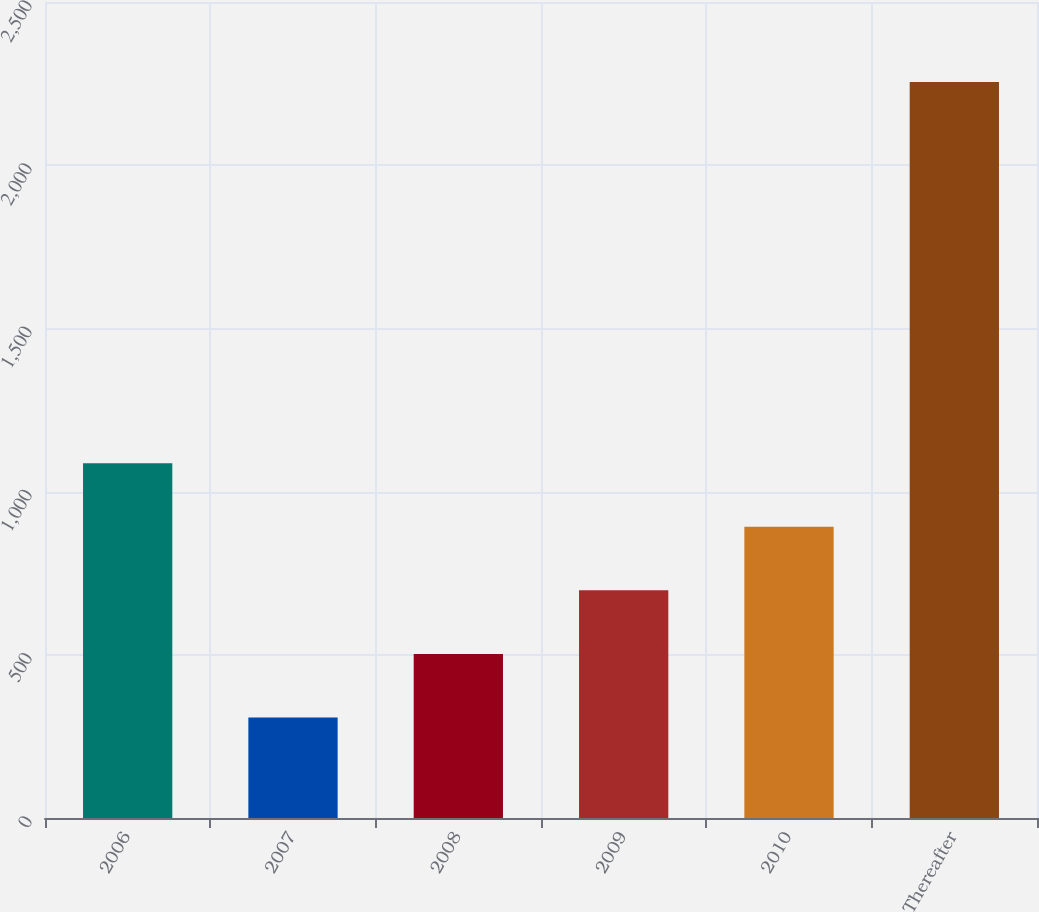<chart> <loc_0><loc_0><loc_500><loc_500><bar_chart><fcel>2006<fcel>2007<fcel>2008<fcel>2009<fcel>2010<fcel>Thereafter<nl><fcel>1086.8<fcel>308<fcel>502.7<fcel>697.4<fcel>892.1<fcel>2255<nl></chart> 